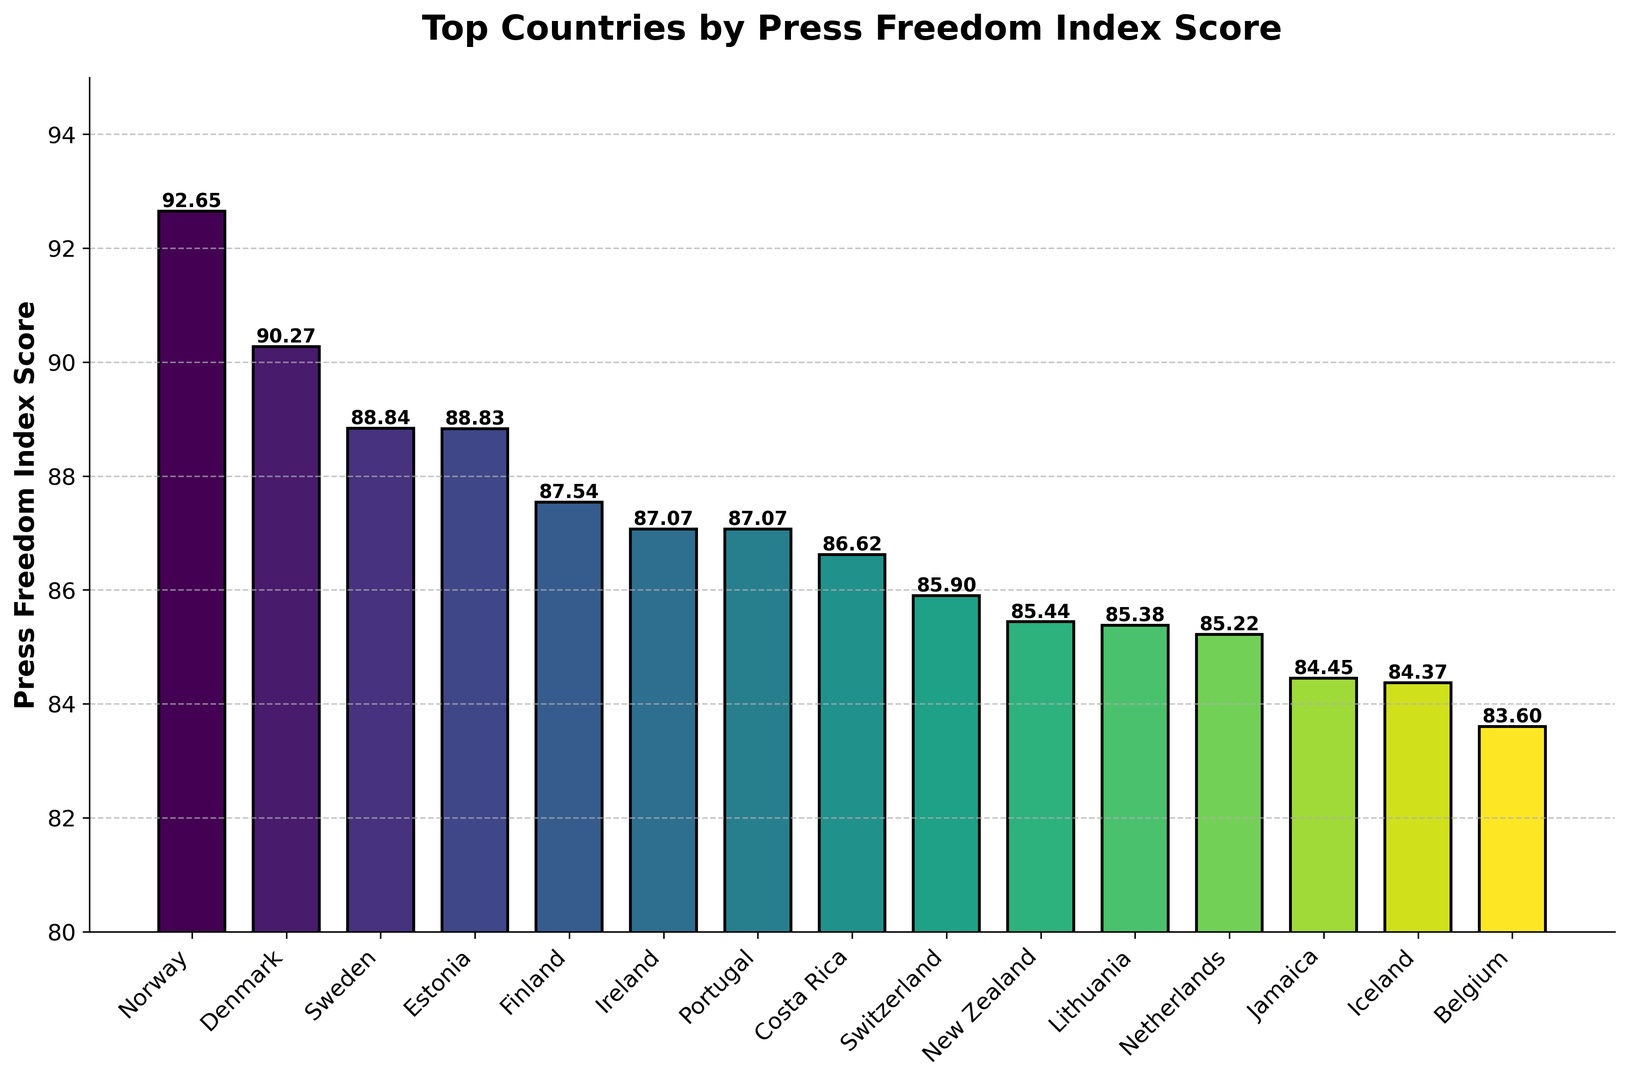What is the country with the highest Press Freedom Index Score? First, identify the tallest bar in the bar chart, which represents the highest score. The top of this bar will label the country and its score.
Answer: Norway Which countries have Press Freedom Index Scores higher than 90? Find and list the countries whose bars reach above the 90 mark on the y-axis.
Answer: Norway, Denmark How many countries have Press Freedom Index Scores between 85 and 90? Count the bars that fall within the 85 to 90 range on the y-axis.
Answer: 7 What is the average Press Freedom Index Score of the shown countries? Add all the Press Freedom Index Scores and divide by the number of countries displayed.
Answer: (92.65 + 90.27 + 88.84 + 88.83 + 87.54 + 87.07 + 87.07 + 86.62 + 85.90 + 85.44 + 85.38 + 85.22 + 84.45 + 84.37 + 83.60) / 15 ≈ 87.11 Which country has a Press Freedom Index Score closest to 85? Identify the bar that is nearest to the 85 mark on the y-axis.
Answer: Lithuania What is the difference in Press Freedom Index Scores between the highest and lowest ranked countries? Subtract the lowest score from the highest score.
Answer: 92.65 - 83.60 = 9.05 How does the length of Norway's bar compare to that of New Zealand's bar? Visually compare the heights of Norway and New Zealand's bars; Norway's bar is significantly longer (higher score).
Answer: Norway's bar is longer Which country appears immediately after Estonia in the ranking? Identify the bar labeled Estonia and note the country next to it in descending order.
Answer: Finland 